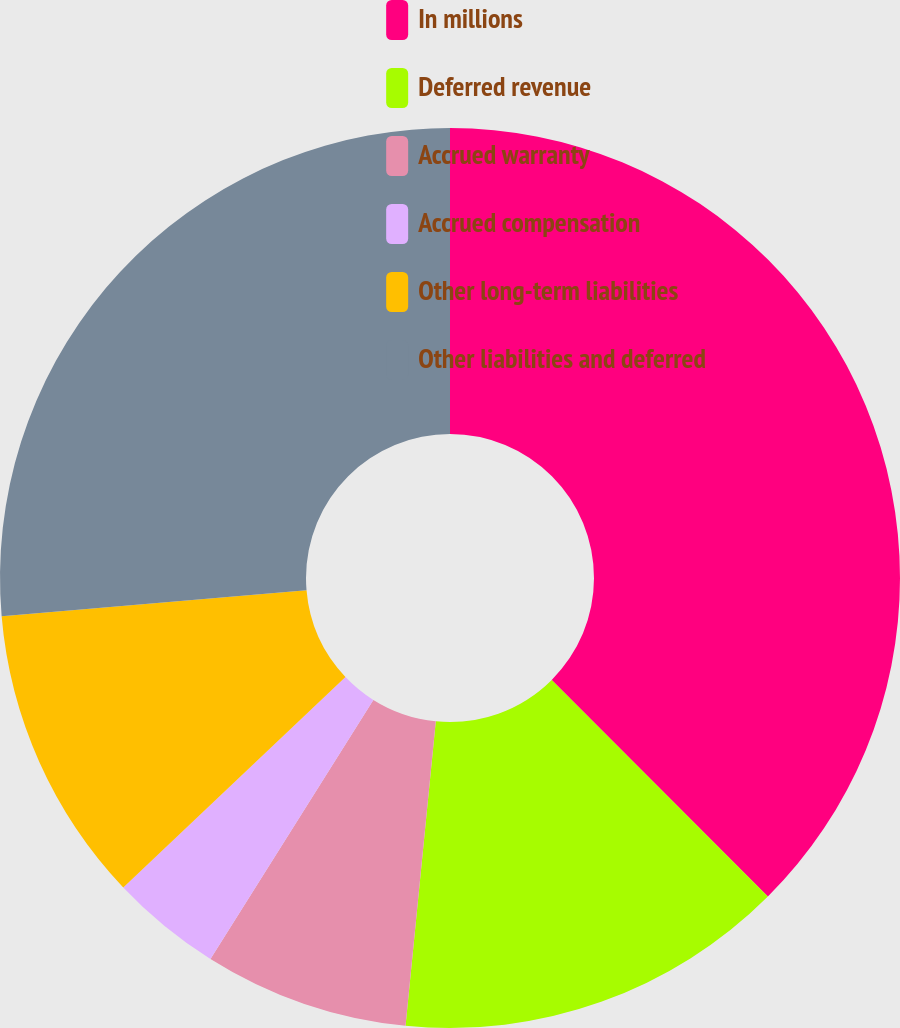Convert chart to OTSL. <chart><loc_0><loc_0><loc_500><loc_500><pie_chart><fcel>In millions<fcel>Deferred revenue<fcel>Accrued warranty<fcel>Accrued compensation<fcel>Other long-term liabilities<fcel>Other liabilities and deferred<nl><fcel>37.52%<fcel>14.06%<fcel>7.36%<fcel>4.0%<fcel>10.71%<fcel>26.36%<nl></chart> 